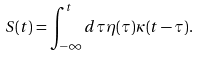Convert formula to latex. <formula><loc_0><loc_0><loc_500><loc_500>S ( t ) = \int _ { - \infty } ^ { t } d \tau \eta ( \tau ) \kappa ( t - \tau ) .</formula> 